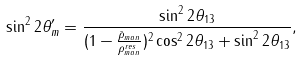<formula> <loc_0><loc_0><loc_500><loc_500>\sin ^ { 2 } 2 \theta ^ { \prime } _ { m } = \frac { \sin ^ { 2 } 2 \theta _ { 1 3 } } { ( 1 - \frac { \bar { \rho } _ { m a n } } { \rho ^ { r e s } _ { m a n } } ) ^ { 2 } \cos ^ { 2 } 2 \theta _ { 1 3 } + \sin ^ { 2 } 2 \theta _ { 1 3 } } ,</formula> 